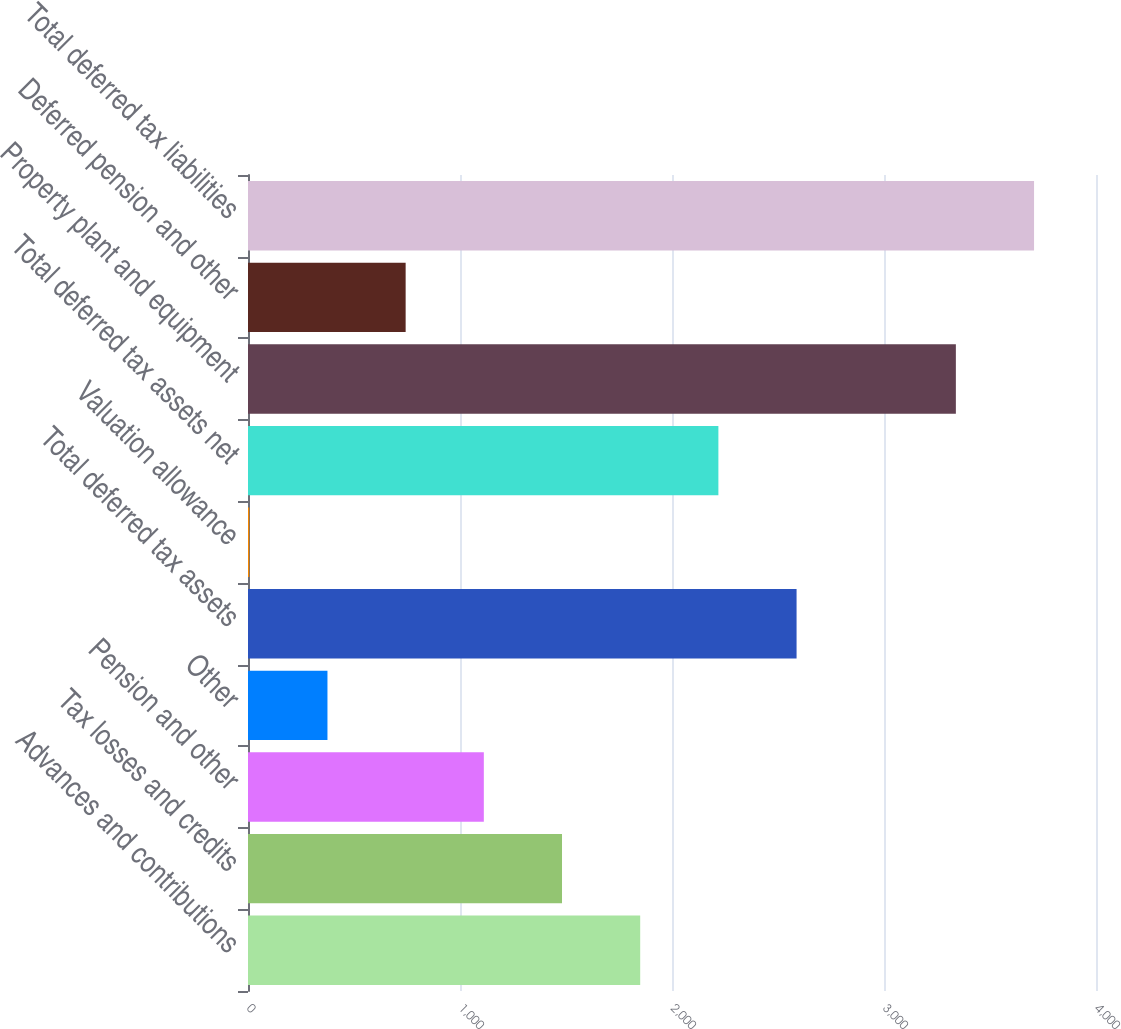<chart> <loc_0><loc_0><loc_500><loc_500><bar_chart><fcel>Advances and contributions<fcel>Tax losses and credits<fcel>Pension and other<fcel>Other<fcel>Total deferred tax assets<fcel>Valuation allowance<fcel>Total deferred tax assets net<fcel>Property plant and equipment<fcel>Deferred pension and other<fcel>Total deferred tax liabilities<nl><fcel>1850<fcel>1481.2<fcel>1112.4<fcel>374.8<fcel>2587.6<fcel>6<fcel>2218.8<fcel>3339<fcel>743.6<fcel>3707.8<nl></chart> 